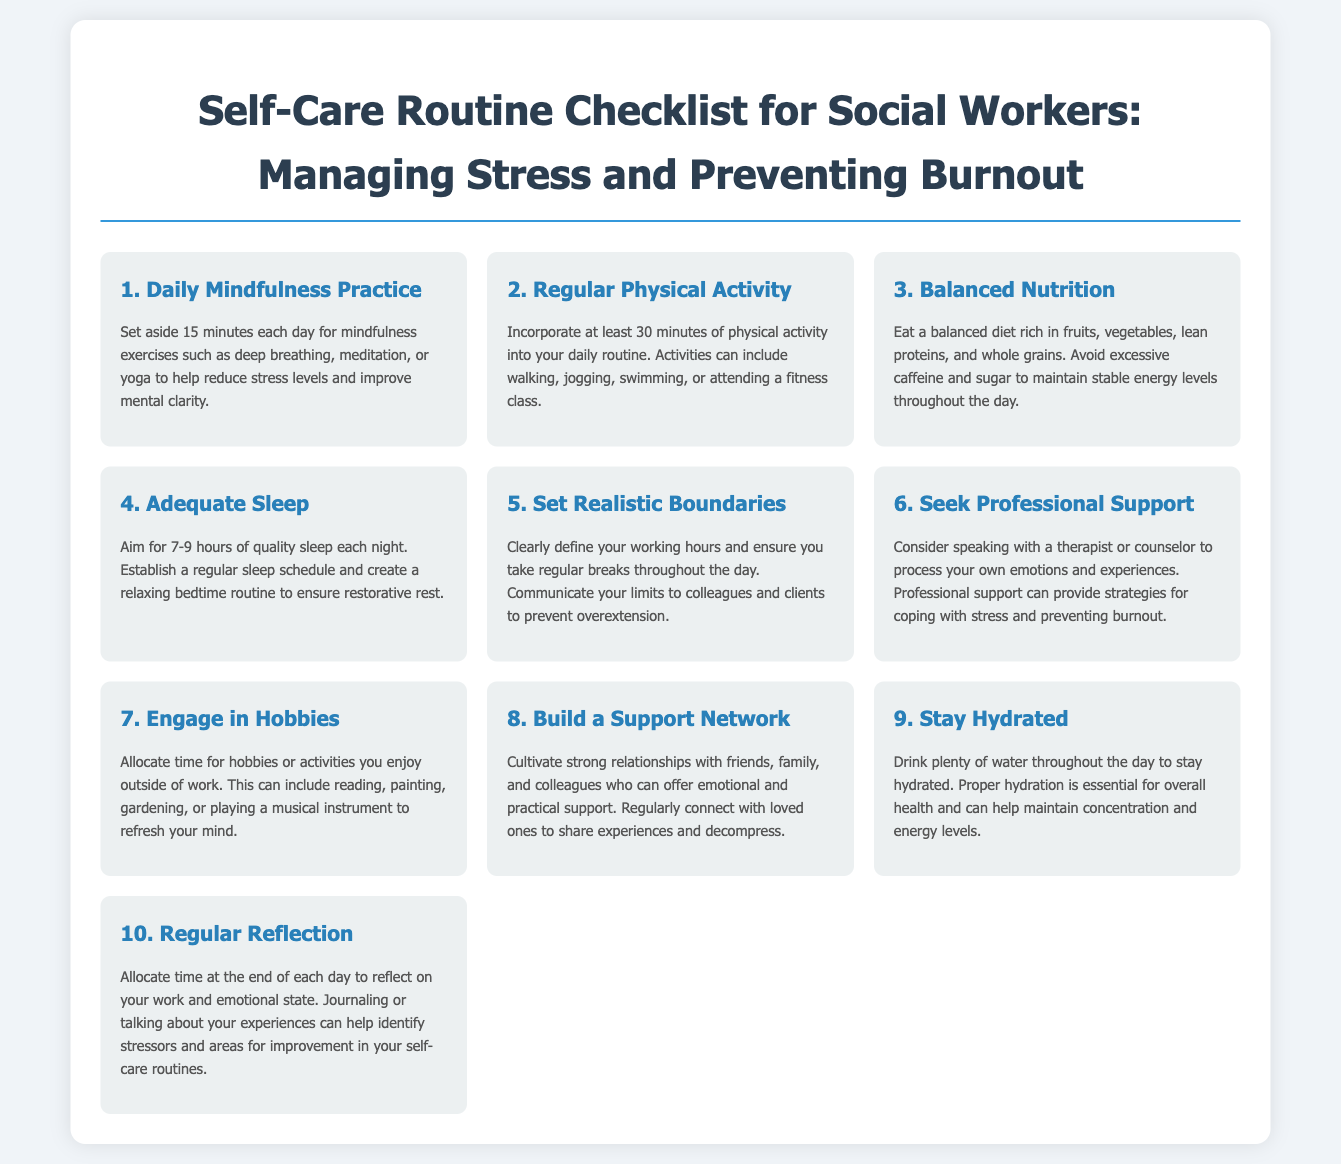what is the title of the checklist? The title is presented at the top of the document, indicating the main focus of the infographic for social workers.
Answer: Self-Care Routine Checklist for Social Workers: Managing Stress and Preventing Burnout how many minutes should be set aside for daily mindfulness practice? The document specifies the duration recommended for mindfulness exercises in the first checklist item.
Answer: 15 minutes what is the minimum duration of physical activity recommended per day? The second checklist item mentions the minimum time for engaging in physical activities to maintain well-being.
Answer: 30 minutes what type of support does the sixth checklist item suggest seeking? This item highlights the kind of professional help recommended for dealing with stress.
Answer: Professional Support name one activity suggested for engaging in hobbies. The seventh checklist item lists examples of leisure activities that can help refresh one's mind outside of work.
Answer: Reading 